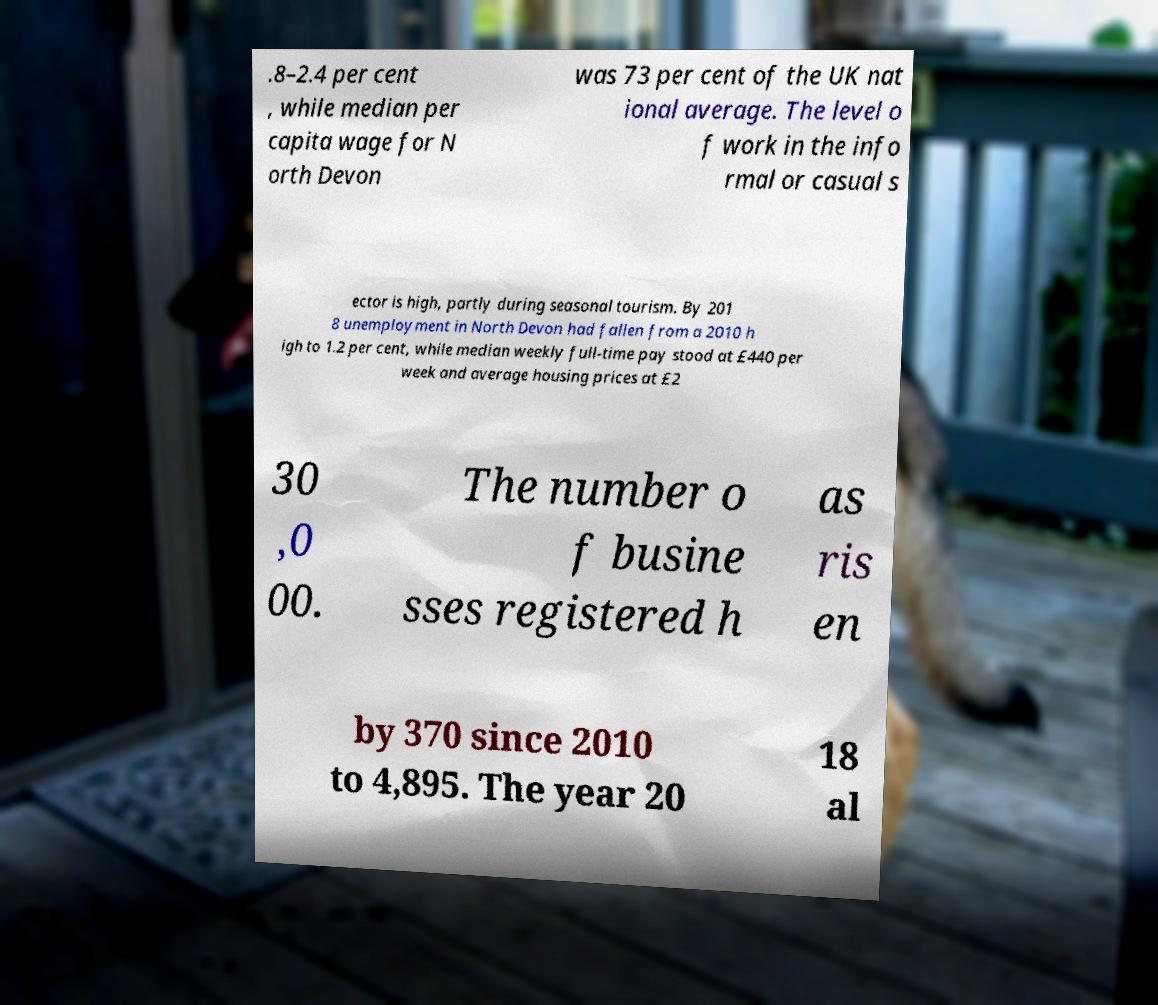Please identify and transcribe the text found in this image. .8–2.4 per cent , while median per capita wage for N orth Devon was 73 per cent of the UK nat ional average. The level o f work in the info rmal or casual s ector is high, partly during seasonal tourism. By 201 8 unemployment in North Devon had fallen from a 2010 h igh to 1.2 per cent, while median weekly full-time pay stood at £440 per week and average housing prices at £2 30 ,0 00. The number o f busine sses registered h as ris en by 370 since 2010 to 4,895. The year 20 18 al 